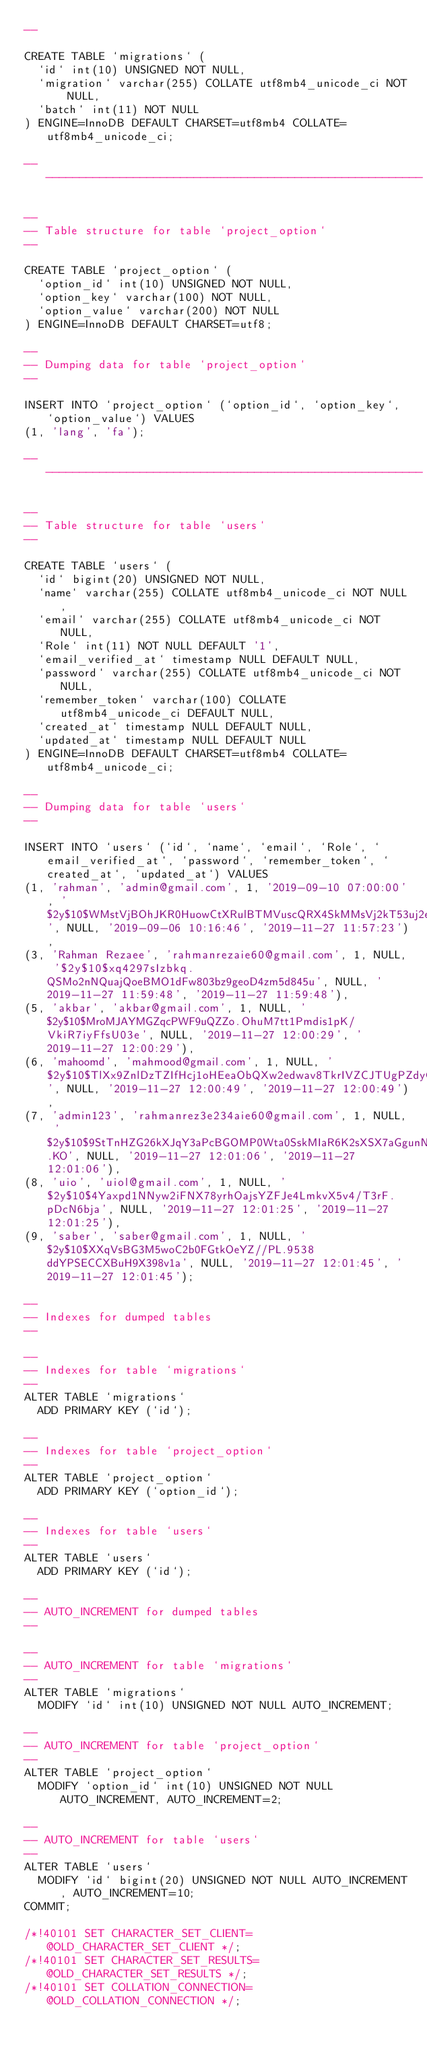<code> <loc_0><loc_0><loc_500><loc_500><_SQL_>--

CREATE TABLE `migrations` (
  `id` int(10) UNSIGNED NOT NULL,
  `migration` varchar(255) COLLATE utf8mb4_unicode_ci NOT NULL,
  `batch` int(11) NOT NULL
) ENGINE=InnoDB DEFAULT CHARSET=utf8mb4 COLLATE=utf8mb4_unicode_ci;

-- --------------------------------------------------------

--
-- Table structure for table `project_option`
--

CREATE TABLE `project_option` (
  `option_id` int(10) UNSIGNED NOT NULL,
  `option_key` varchar(100) NOT NULL,
  `option_value` varchar(200) NOT NULL
) ENGINE=InnoDB DEFAULT CHARSET=utf8;

--
-- Dumping data for table `project_option`
--

INSERT INTO `project_option` (`option_id`, `option_key`, `option_value`) VALUES
(1, 'lang', 'fa');

-- --------------------------------------------------------

--
-- Table structure for table `users`
--

CREATE TABLE `users` (
  `id` bigint(20) UNSIGNED NOT NULL,
  `name` varchar(255) COLLATE utf8mb4_unicode_ci NOT NULL,
  `email` varchar(255) COLLATE utf8mb4_unicode_ci NOT NULL,
  `Role` int(11) NOT NULL DEFAULT '1',
  `email_verified_at` timestamp NULL DEFAULT NULL,
  `password` varchar(255) COLLATE utf8mb4_unicode_ci NOT NULL,
  `remember_token` varchar(100) COLLATE utf8mb4_unicode_ci DEFAULT NULL,
  `created_at` timestamp NULL DEFAULT NULL,
  `updated_at` timestamp NULL DEFAULT NULL
) ENGINE=InnoDB DEFAULT CHARSET=utf8mb4 COLLATE=utf8mb4_unicode_ci;

--
-- Dumping data for table `users`
--

INSERT INTO `users` (`id`, `name`, `email`, `Role`, `email_verified_at`, `password`, `remember_token`, `created_at`, `updated_at`) VALUES
(1, 'rahman', 'admin@gmail.com', 1, '2019-09-10 07:00:00', '$2y$10$WMstVjBOhJKR0HuowCtXRulBTMVuscQRX4SkMMsVj2kT53uj2eEpa', NULL, '2019-09-06 10:16:46', '2019-11-27 11:57:23'),
(3, 'Rahman Rezaee', 'rahmanrezaie60@gmail.com', 1, NULL, '$2y$10$xq4297sIzbkq.QSMo2nNQuajQoeBMO1dFw803bz9geoD4zm5d845u', NULL, '2019-11-27 11:59:48', '2019-11-27 11:59:48'),
(5, 'akbar', 'akbar@gmail.com', 1, NULL, '$2y$10$MroMJAYMGZqcPWF9uQZZo.OhuM7tt1Pmdis1pK/VkiR7iyFfsU03e', NULL, '2019-11-27 12:00:29', '2019-11-27 12:00:29'),
(6, 'mahoomd', 'mahmood@gmail.com', 1, NULL, '$2y$10$TlXx9ZnlDzTZIfHcj1oHEeaObQXw2edwav8TkrIVZCJTUgPZdyOhG', NULL, '2019-11-27 12:00:49', '2019-11-27 12:00:49'),
(7, 'admin123', 'rahmanrez3e234aie60@gmail.com', 1, NULL, '$2y$10$9StTnHZG26kXJqY3aPcBGOMP0Wta0SskMIaR6K2sXSX7aGgunN.KO', NULL, '2019-11-27 12:01:06', '2019-11-27 12:01:06'),
(8, 'uio', 'uiol@gmail.com', 1, NULL, '$2y$10$4Yaxpd1NNyw2iFNX78yrhOajsYZFJe4LmkvX5v4/T3rF.pDcN6bja', NULL, '2019-11-27 12:01:25', '2019-11-27 12:01:25'),
(9, 'saber', 'saber@gmail.com', 1, NULL, '$2y$10$XXqVsBG3M5woC2b0FGtkOeYZ//PL.9538ddYPSECCXBuH9X398v1a', NULL, '2019-11-27 12:01:45', '2019-11-27 12:01:45');

--
-- Indexes for dumped tables
--

--
-- Indexes for table `migrations`
--
ALTER TABLE `migrations`
  ADD PRIMARY KEY (`id`);

--
-- Indexes for table `project_option`
--
ALTER TABLE `project_option`
  ADD PRIMARY KEY (`option_id`);

--
-- Indexes for table `users`
--
ALTER TABLE `users`
  ADD PRIMARY KEY (`id`);

--
-- AUTO_INCREMENT for dumped tables
--

--
-- AUTO_INCREMENT for table `migrations`
--
ALTER TABLE `migrations`
  MODIFY `id` int(10) UNSIGNED NOT NULL AUTO_INCREMENT;

--
-- AUTO_INCREMENT for table `project_option`
--
ALTER TABLE `project_option`
  MODIFY `option_id` int(10) UNSIGNED NOT NULL AUTO_INCREMENT, AUTO_INCREMENT=2;

--
-- AUTO_INCREMENT for table `users`
--
ALTER TABLE `users`
  MODIFY `id` bigint(20) UNSIGNED NOT NULL AUTO_INCREMENT, AUTO_INCREMENT=10;
COMMIT;

/*!40101 SET CHARACTER_SET_CLIENT=@OLD_CHARACTER_SET_CLIENT */;
/*!40101 SET CHARACTER_SET_RESULTS=@OLD_CHARACTER_SET_RESULTS */;
/*!40101 SET COLLATION_CONNECTION=@OLD_COLLATION_CONNECTION */;
</code> 